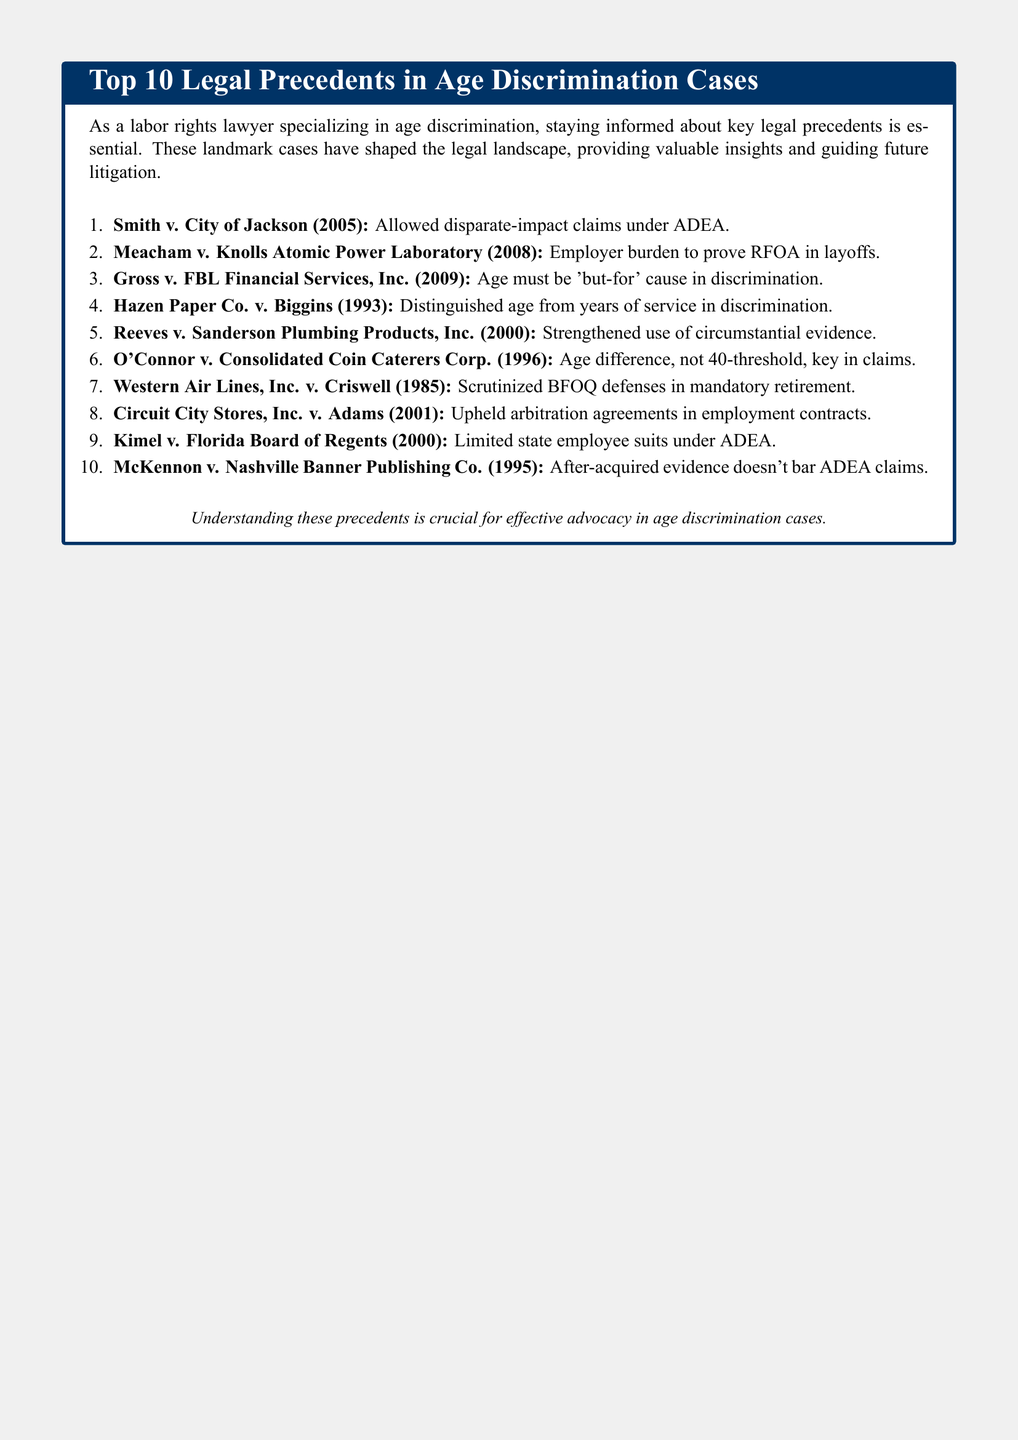What was decided in Smith v. City of Jackson? The case allowed disparate-impact claims under ADEA.
Answer: Allowed disparate-impact claims under ADEA What year was Meacham v. Knolls Atomic Power Laboratory decided? The decision was made in the year 2008.
Answer: 2008 What is the significance of Gross v. FBL Financial Services, Inc.? The case established that age must be a 'but-for' cause in discrimination.
Answer: Age must be 'but-for' cause Which precedent distinguished age from years of service? The case is Hazen Paper Co. v. Biggins.
Answer: Hazen Paper Co. v. Biggins What critical element did O'Connor v. Consolidated Coin Caterers Corp. focus on? The case emphasized that age difference, not 40-threshold, is key in claims.
Answer: Age difference, not 40-threshold What type of legal agreement was upheld in Circuit City Stores, Inc. v. Adams? The case upheld arbitration agreements in employment contracts.
Answer: Arbitration agreements How many cases are listed in the document? The document lists a total of 10 cases.
Answer: 10 What is the main purpose of the document? The document aims to provide valuable insights for effective advocacy in age discrimination cases.
Answer: Effective advocacy in age discrimination cases 